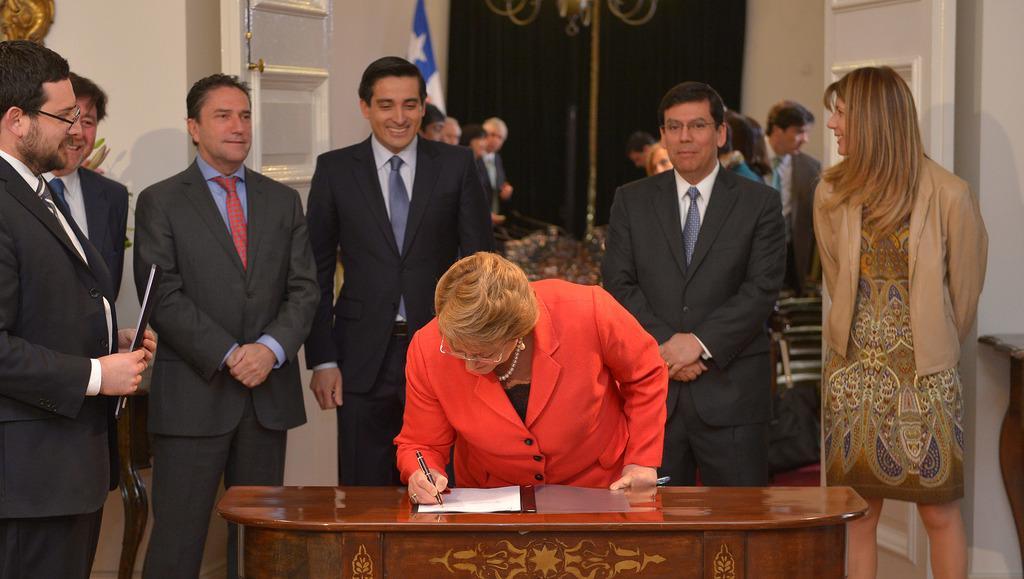Describe this image in one or two sentences. In this image I can see few people are standing. In the middle of the image there is a woman wearing red color jacket and writing something on the paper with a pen. In the background I can see a blue color curtain, one flag and there is a wall. 